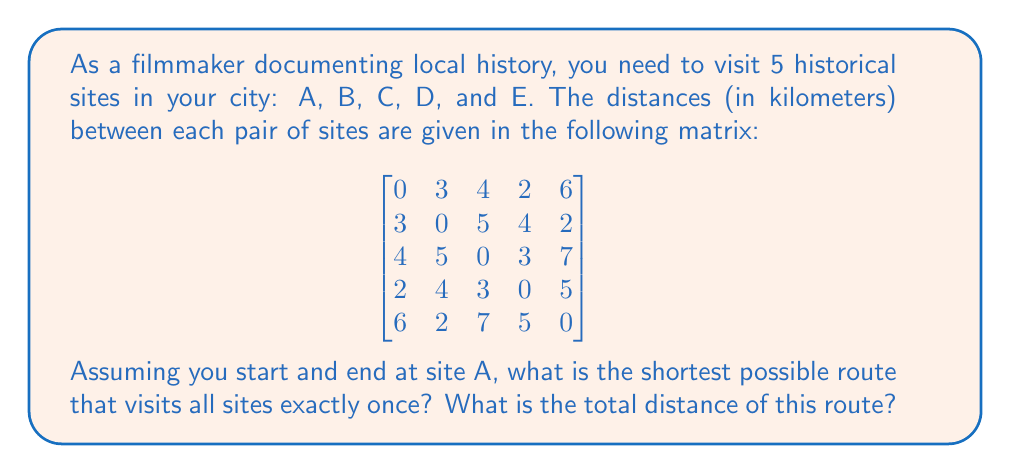Teach me how to tackle this problem. This problem is an instance of the Traveling Salesman Problem (TSP). To solve it, we need to consider all possible permutations of the sites (excluding A at the start and end) and calculate the total distance for each route.

The possible routes are:
1. A-B-C-D-E-A
2. A-B-C-E-D-A
3. A-B-D-C-E-A
4. A-B-D-E-C-A
5. A-B-E-C-D-A
6. A-B-E-D-C-A
7. A-C-B-D-E-A
8. A-C-B-E-D-A
9. A-C-D-B-E-A
10. A-C-D-E-B-A
11. A-C-E-B-D-A
12. A-C-E-D-B-A

Let's calculate the distance for each route:

1. A-B-C-D-E-A: $3 + 5 + 3 + 5 + 6 = 22$ km
2. A-B-C-E-D-A: $3 + 5 + 7 + 5 + 2 = 22$ km
3. A-B-D-C-E-A: $3 + 4 + 3 + 7 + 6 = 23$ km
4. A-B-D-E-C-A: $3 + 4 + 5 + 7 + 4 = 23$ km
5. A-B-E-C-D-A: $3 + 2 + 7 + 3 + 2 = 17$ km
6. A-B-E-D-C-A: $3 + 2 + 5 + 3 + 4 = 17$ km
7. A-C-B-D-E-A: $4 + 5 + 4 + 5 + 6 = 24$ km
8. A-C-B-E-D-A: $4 + 5 + 2 + 5 + 2 = 18$ km
9. A-C-D-B-E-A: $4 + 3 + 4 + 2 + 6 = 19$ km
10. A-C-D-E-B-A: $4 + 3 + 5 + 2 + 3 = 17$ km
11. A-C-E-B-D-A: $4 + 7 + 2 + 4 + 2 = 19$ km
12. A-C-E-D-B-A: $4 + 7 + 5 + 4 + 3 = 23$ km

The shortest routes are:
- A-B-E-C-D-A
- A-B-E-D-C-A
- A-C-D-E-B-A

All of these have a total distance of 17 km.
Answer: The shortest possible route is either A-B-E-C-D-A, A-B-E-D-C-A, or A-C-D-E-B-A, with a total distance of 17 km. 